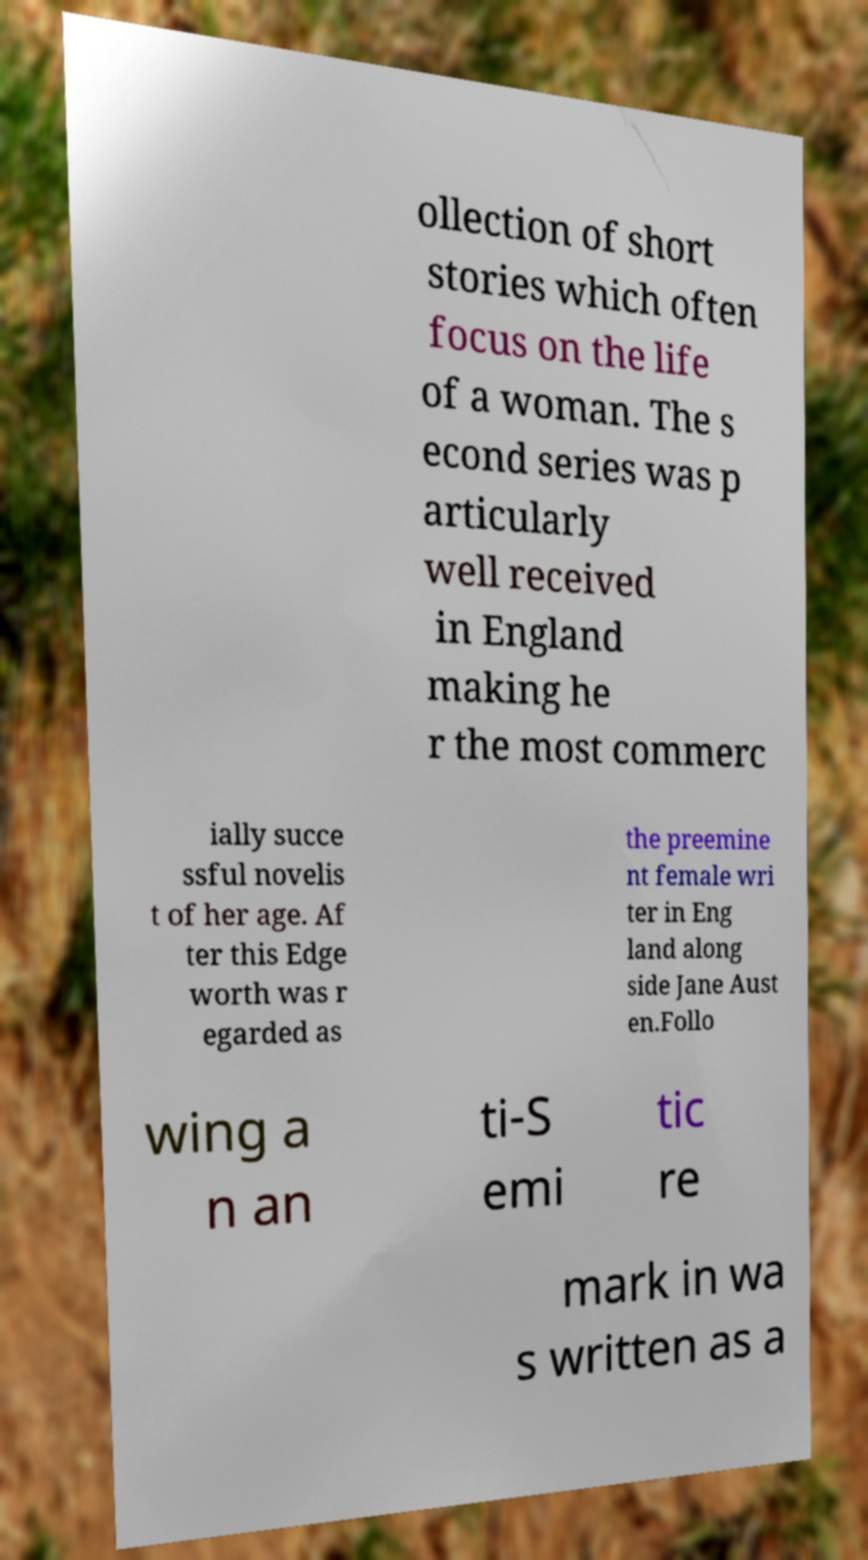Please read and relay the text visible in this image. What does it say? ollection of short stories which often focus on the life of a woman. The s econd series was p articularly well received in England making he r the most commerc ially succe ssful novelis t of her age. Af ter this Edge worth was r egarded as the preemine nt female wri ter in Eng land along side Jane Aust en.Follo wing a n an ti-S emi tic re mark in wa s written as a 